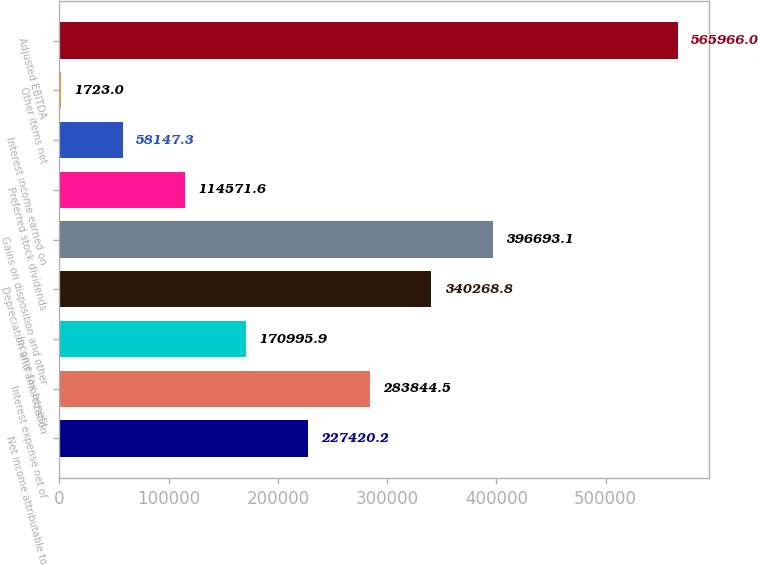Convert chart to OTSL. <chart><loc_0><loc_0><loc_500><loc_500><bar_chart><fcel>Net income attributable to<fcel>Interest expense net of<fcel>Income tax benefit<fcel>Depreciation and amortization<fcel>Gains on disposition and other<fcel>Preferred stock dividends<fcel>Interest income earned on<fcel>Other items net<fcel>Adjusted EBITDA<nl><fcel>227420<fcel>283844<fcel>170996<fcel>340269<fcel>396693<fcel>114572<fcel>58147.3<fcel>1723<fcel>565966<nl></chart> 